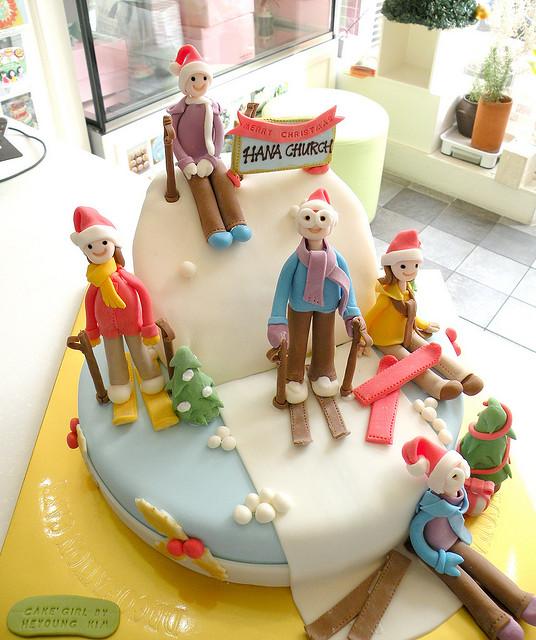What character is wearing the red shirt?
Give a very brief answer. One on left. What is written on the cake?
Be succinct. Hana church. Are there snowballs on the cake?
Write a very short answer. Yes. Is this a toy?
Concise answer only. No. 